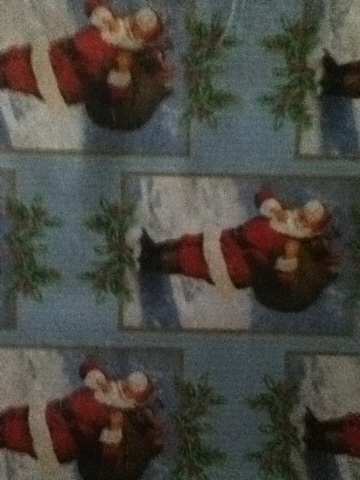Does the wrapping paper include any other festive symbols besides Santa Claus? Along with Santa Claus, the wrapping paper includes images of mistletoe, which is another festive symbol commonly associated with the Christmas season. The combination of Santa Claus and mistletoe enhances the holiday theme of the wrapping paper. 